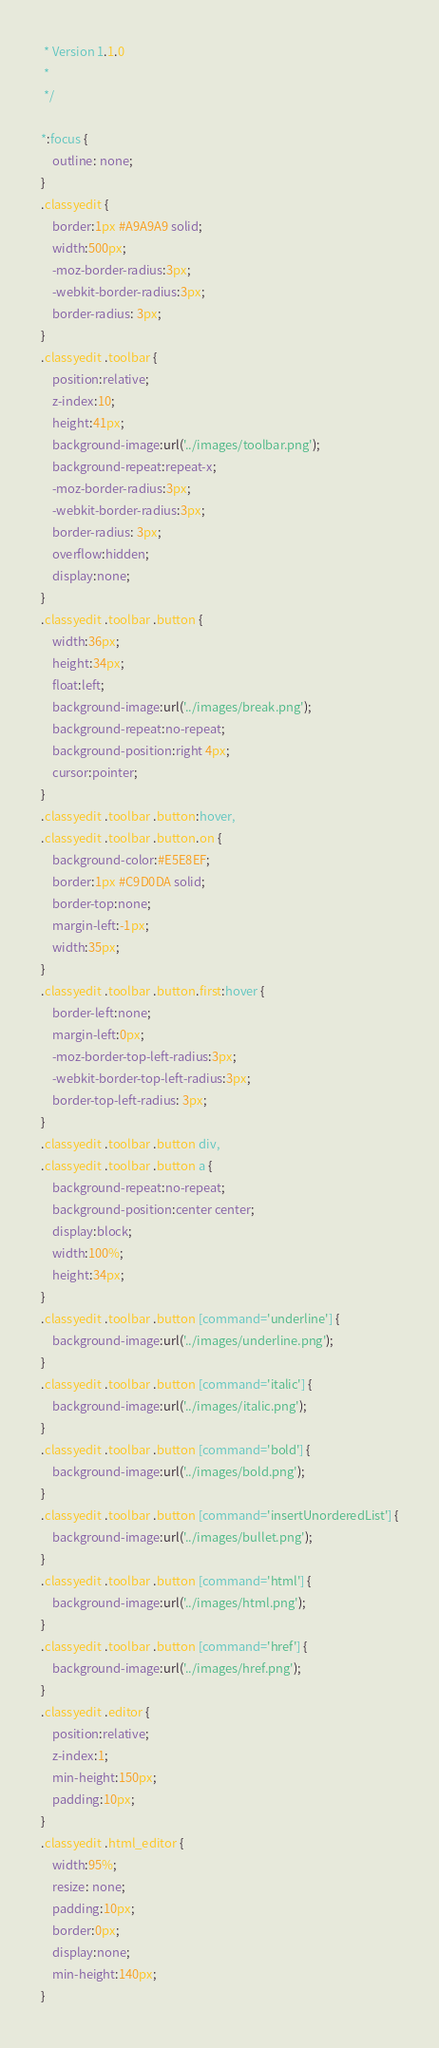<code> <loc_0><loc_0><loc_500><loc_500><_CSS_> * Version 1.1.0
 *
 */

*:focus {
    outline: none;  
}
.classyedit {
    border:1px #A9A9A9 solid;
    width:500px;
    -moz-border-radius:3px;
    -webkit-border-radius:3px;
    border-radius: 3px;
}
.classyedit .toolbar {
    position:relative;
    z-index:10;
    height:41px;
    background-image:url('../images/toolbar.png');
    background-repeat:repeat-x;
    -moz-border-radius:3px;
    -webkit-border-radius:3px;
    border-radius: 3px;
    overflow:hidden;
    display:none;
}
.classyedit .toolbar .button {
    width:36px;
    height:34px;
    float:left;
    background-image:url('../images/break.png');
    background-repeat:no-repeat;
    background-position:right 4px;
    cursor:pointer;
}
.classyedit .toolbar .button:hover,
.classyedit .toolbar .button.on {
    background-color:#E5E8EF;
    border:1px #C9D0DA solid;
    border-top:none;
    margin-left:-1px;
    width:35px;
}
.classyedit .toolbar .button.first:hover {
    border-left:none;
    margin-left:0px;
    -moz-border-top-left-radius:3px;
    -webkit-border-top-left-radius:3px;
    border-top-left-radius: 3px;
}
.classyedit .toolbar .button div,
.classyedit .toolbar .button a {
    background-repeat:no-repeat;
    background-position:center center;
    display:block;
    width:100%;
    height:34px;
}
.classyedit .toolbar .button [command='underline'] {
    background-image:url('../images/underline.png');
}
.classyedit .toolbar .button [command='italic'] {
    background-image:url('../images/italic.png');
}
.classyedit .toolbar .button [command='bold'] {
    background-image:url('../images/bold.png');
}
.classyedit .toolbar .button [command='insertUnorderedList'] {
    background-image:url('../images/bullet.png');
}
.classyedit .toolbar .button [command='html'] {
    background-image:url('../images/html.png');
}
.classyedit .toolbar .button [command='href'] {
    background-image:url('../images/href.png');
}
.classyedit .editor {
    position:relative;
    z-index:1;
    min-height:150px;
    padding:10px;
}
.classyedit .html_editor {
    width:95%;
    resize: none;
    padding:10px;
    border:0px;
    display:none;
    min-height:140px;
}</code> 